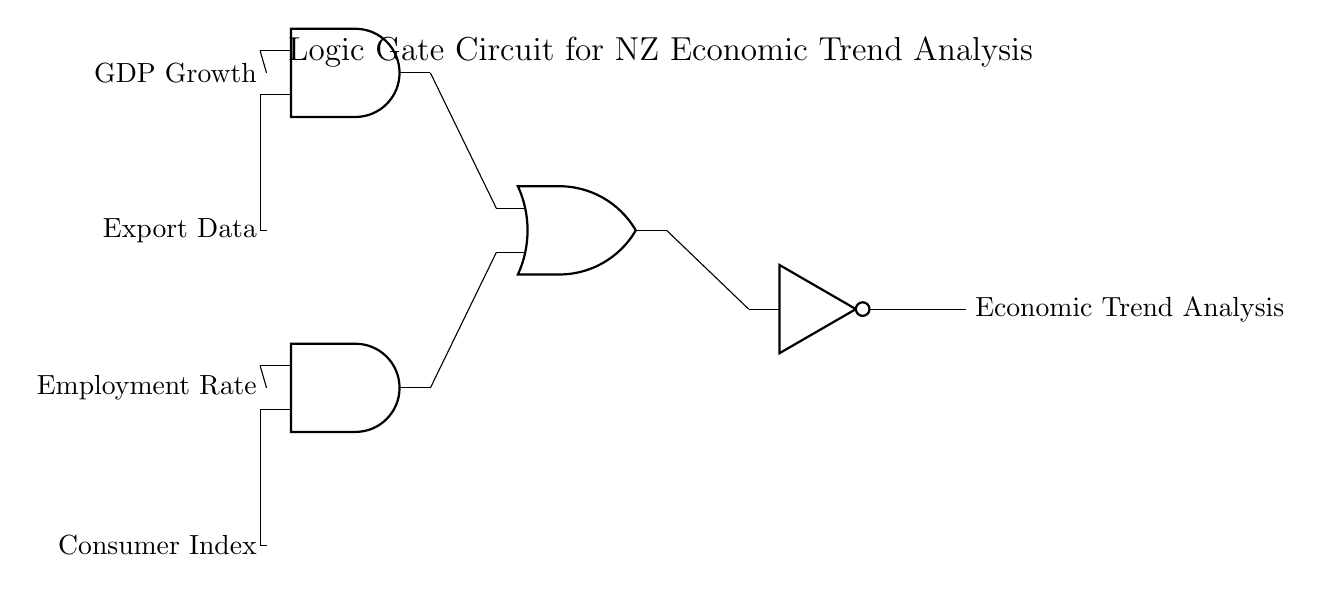What are the inputs of the logic gate circuit? The inputs are GDP Growth, Export Data, Employment Rate, and Consumer Index, which can be seen as the lines connecting these labels to the logic gates.
Answer: GDP Growth, Export Data, Employment Rate, Consumer Index What type of logic gate is used to combine GDP Growth and Export Data? The circuit shows an AND gate (represented by the "and port" symbol), which combines these two inputs, signifying that both must be true for a positive output.
Answer: AND What is the function of the NOT gate in this circuit? The NOT gate inverts the output signal from the OR gate, indicating it takes whatever the output of the OR gate is and flips it to its opposite state.
Answer: Inversion How many AND gates are present in the circuit? The circuit diagram shows two AND gates, which are indicated by two "and port" symbols in the drawing.
Answer: Two What does the output of the logic gate circuit represent? The output line labeled "Economic Trend Analysis" indicates the final result provided by the circuit after processing the inputs; it represents the analysis of economic trends based on the provided data.
Answer: Economic Trend Analysis Which logical operation does the OR gate perform in this context? The OR gate combines the outputs of the two AND gates, meaning if either AND gate gives a true signal, the OR gate will also output a true signal, representing an aggregated analysis.
Answer: Aggregation What is the relationship between the Employment Rate and Consumer Index in this circuit? The circuit uses an AND gate to evaluate both the Employment Rate and Consumer Index, suggesting that they need to be jointly considered for a comprehensive economic assessment.
Answer: Joint consideration 